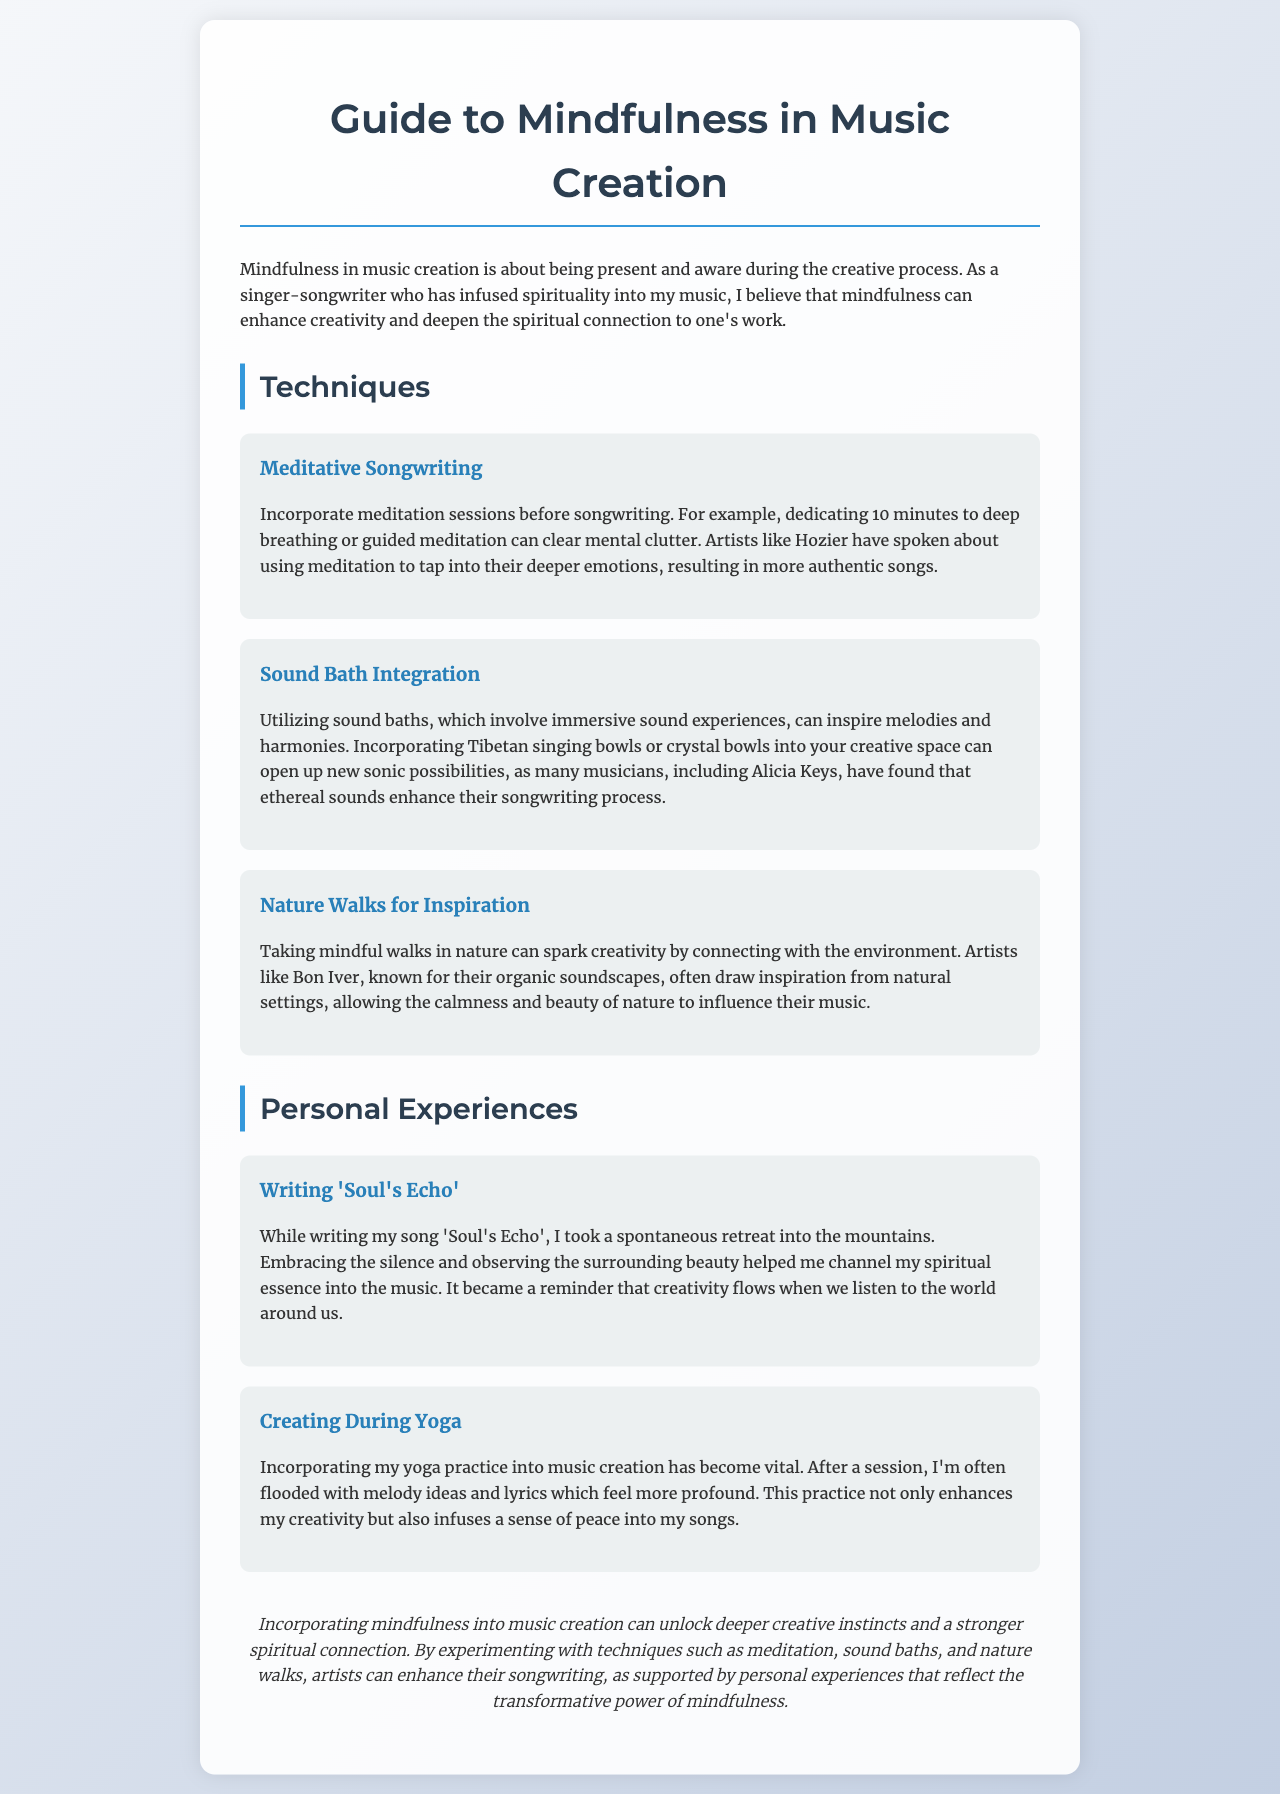What is the title of the document? The title is the main heading of the document, which introduces its content.
Answer: Guide to Mindfulness in Music Creation What technique involves meditation before songwriting? This is found in the Techniques section and specifically highlights a method for enhancing creativity.
Answer: Meditative Songwriting Who is mentioned as having benefited from sound baths? This question looks for a name referenced in the context of sound bath integration in the document.
Answer: Alicia Keys What is the focus of the personal experience while writing 'Soul's Echo'? The personal experience discusses the context and inspiration behind the creation of a specific song.
Answer: Silence and surrounding beauty How does yoga influence music creation? This question seeks to understand the impact of a specific practice on the songwriting process as described in the document.
Answer: Melody ideas and profound lyrics What is a common setting for nature-inspired creativity mentioned? The document refers to a type of setting that artists use for inspiration in their music.
Answer: Natural settings What is the conclusion of the document about mindfulness? The conclusion summarizes the overall message of the document regarding mindfulness in music.
Answer: Unlock deeper creative instincts What type of experience is described with creating during yoga? This question examines the nature of the personal experience shared within the document.
Answer: Vital experience 